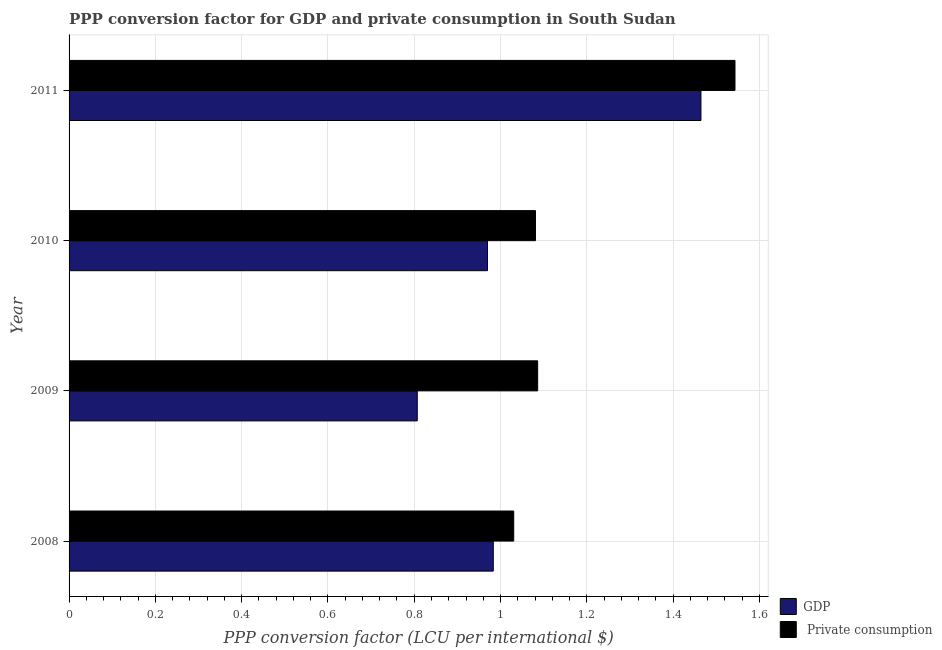How many groups of bars are there?
Keep it short and to the point. 4. Are the number of bars per tick equal to the number of legend labels?
Your answer should be compact. Yes. How many bars are there on the 4th tick from the bottom?
Your response must be concise. 2. In how many cases, is the number of bars for a given year not equal to the number of legend labels?
Give a very brief answer. 0. What is the ppp conversion factor for private consumption in 2008?
Your answer should be very brief. 1.03. Across all years, what is the maximum ppp conversion factor for private consumption?
Your response must be concise. 1.54. Across all years, what is the minimum ppp conversion factor for private consumption?
Keep it short and to the point. 1.03. What is the total ppp conversion factor for private consumption in the graph?
Your response must be concise. 4.74. What is the difference between the ppp conversion factor for gdp in 2009 and that in 2010?
Make the answer very short. -0.16. What is the difference between the ppp conversion factor for private consumption in 2009 and the ppp conversion factor for gdp in 2010?
Offer a very short reply. 0.12. What is the average ppp conversion factor for gdp per year?
Make the answer very short. 1.06. In the year 2009, what is the difference between the ppp conversion factor for private consumption and ppp conversion factor for gdp?
Provide a succinct answer. 0.28. In how many years, is the ppp conversion factor for private consumption greater than 0.6000000000000001 LCU?
Give a very brief answer. 4. What is the ratio of the ppp conversion factor for private consumption in 2009 to that in 2011?
Make the answer very short. 0.7. Is the ppp conversion factor for private consumption in 2009 less than that in 2010?
Provide a succinct answer. No. What is the difference between the highest and the second highest ppp conversion factor for private consumption?
Your answer should be compact. 0.46. What is the difference between the highest and the lowest ppp conversion factor for gdp?
Ensure brevity in your answer.  0.66. In how many years, is the ppp conversion factor for gdp greater than the average ppp conversion factor for gdp taken over all years?
Ensure brevity in your answer.  1. Is the sum of the ppp conversion factor for gdp in 2008 and 2011 greater than the maximum ppp conversion factor for private consumption across all years?
Provide a short and direct response. Yes. What does the 1st bar from the top in 2009 represents?
Make the answer very short.  Private consumption. What does the 2nd bar from the bottom in 2010 represents?
Ensure brevity in your answer.   Private consumption. How many bars are there?
Your answer should be compact. 8. Are all the bars in the graph horizontal?
Your response must be concise. Yes. How many years are there in the graph?
Your answer should be very brief. 4. Does the graph contain any zero values?
Give a very brief answer. No. What is the title of the graph?
Give a very brief answer. PPP conversion factor for GDP and private consumption in South Sudan. Does "Fertility rate" appear as one of the legend labels in the graph?
Make the answer very short. No. What is the label or title of the X-axis?
Ensure brevity in your answer.  PPP conversion factor (LCU per international $). What is the PPP conversion factor (LCU per international $) in GDP in 2008?
Your answer should be compact. 0.98. What is the PPP conversion factor (LCU per international $) of  Private consumption in 2008?
Ensure brevity in your answer.  1.03. What is the PPP conversion factor (LCU per international $) of GDP in 2009?
Your answer should be very brief. 0.81. What is the PPP conversion factor (LCU per international $) of  Private consumption in 2009?
Provide a short and direct response. 1.09. What is the PPP conversion factor (LCU per international $) in GDP in 2010?
Offer a terse response. 0.97. What is the PPP conversion factor (LCU per international $) in  Private consumption in 2010?
Offer a very short reply. 1.08. What is the PPP conversion factor (LCU per international $) of GDP in 2011?
Provide a short and direct response. 1.46. What is the PPP conversion factor (LCU per international $) in  Private consumption in 2011?
Your response must be concise. 1.54. Across all years, what is the maximum PPP conversion factor (LCU per international $) of GDP?
Your answer should be very brief. 1.46. Across all years, what is the maximum PPP conversion factor (LCU per international $) of  Private consumption?
Your answer should be very brief. 1.54. Across all years, what is the minimum PPP conversion factor (LCU per international $) of GDP?
Give a very brief answer. 0.81. Across all years, what is the minimum PPP conversion factor (LCU per international $) in  Private consumption?
Ensure brevity in your answer.  1.03. What is the total PPP conversion factor (LCU per international $) in GDP in the graph?
Provide a short and direct response. 4.22. What is the total PPP conversion factor (LCU per international $) in  Private consumption in the graph?
Give a very brief answer. 4.74. What is the difference between the PPP conversion factor (LCU per international $) of GDP in 2008 and that in 2009?
Offer a very short reply. 0.18. What is the difference between the PPP conversion factor (LCU per international $) of  Private consumption in 2008 and that in 2009?
Offer a terse response. -0.06. What is the difference between the PPP conversion factor (LCU per international $) of GDP in 2008 and that in 2010?
Keep it short and to the point. 0.01. What is the difference between the PPP conversion factor (LCU per international $) of  Private consumption in 2008 and that in 2010?
Keep it short and to the point. -0.05. What is the difference between the PPP conversion factor (LCU per international $) in GDP in 2008 and that in 2011?
Keep it short and to the point. -0.48. What is the difference between the PPP conversion factor (LCU per international $) of  Private consumption in 2008 and that in 2011?
Your response must be concise. -0.51. What is the difference between the PPP conversion factor (LCU per international $) in GDP in 2009 and that in 2010?
Your answer should be very brief. -0.16. What is the difference between the PPP conversion factor (LCU per international $) in  Private consumption in 2009 and that in 2010?
Keep it short and to the point. 0.01. What is the difference between the PPP conversion factor (LCU per international $) of GDP in 2009 and that in 2011?
Your answer should be compact. -0.66. What is the difference between the PPP conversion factor (LCU per international $) of  Private consumption in 2009 and that in 2011?
Provide a succinct answer. -0.46. What is the difference between the PPP conversion factor (LCU per international $) of GDP in 2010 and that in 2011?
Your answer should be compact. -0.49. What is the difference between the PPP conversion factor (LCU per international $) in  Private consumption in 2010 and that in 2011?
Your response must be concise. -0.46. What is the difference between the PPP conversion factor (LCU per international $) of GDP in 2008 and the PPP conversion factor (LCU per international $) of  Private consumption in 2009?
Offer a very short reply. -0.1. What is the difference between the PPP conversion factor (LCU per international $) in GDP in 2008 and the PPP conversion factor (LCU per international $) in  Private consumption in 2010?
Make the answer very short. -0.1. What is the difference between the PPP conversion factor (LCU per international $) in GDP in 2008 and the PPP conversion factor (LCU per international $) in  Private consumption in 2011?
Your answer should be compact. -0.56. What is the difference between the PPP conversion factor (LCU per international $) of GDP in 2009 and the PPP conversion factor (LCU per international $) of  Private consumption in 2010?
Ensure brevity in your answer.  -0.27. What is the difference between the PPP conversion factor (LCU per international $) of GDP in 2009 and the PPP conversion factor (LCU per international $) of  Private consumption in 2011?
Ensure brevity in your answer.  -0.74. What is the difference between the PPP conversion factor (LCU per international $) of GDP in 2010 and the PPP conversion factor (LCU per international $) of  Private consumption in 2011?
Your response must be concise. -0.57. What is the average PPP conversion factor (LCU per international $) of GDP per year?
Provide a short and direct response. 1.06. What is the average PPP conversion factor (LCU per international $) of  Private consumption per year?
Your answer should be compact. 1.19. In the year 2008, what is the difference between the PPP conversion factor (LCU per international $) in GDP and PPP conversion factor (LCU per international $) in  Private consumption?
Make the answer very short. -0.05. In the year 2009, what is the difference between the PPP conversion factor (LCU per international $) of GDP and PPP conversion factor (LCU per international $) of  Private consumption?
Give a very brief answer. -0.28. In the year 2010, what is the difference between the PPP conversion factor (LCU per international $) of GDP and PPP conversion factor (LCU per international $) of  Private consumption?
Your answer should be very brief. -0.11. In the year 2011, what is the difference between the PPP conversion factor (LCU per international $) in GDP and PPP conversion factor (LCU per international $) in  Private consumption?
Ensure brevity in your answer.  -0.08. What is the ratio of the PPP conversion factor (LCU per international $) in GDP in 2008 to that in 2009?
Offer a terse response. 1.22. What is the ratio of the PPP conversion factor (LCU per international $) of  Private consumption in 2008 to that in 2009?
Your answer should be compact. 0.95. What is the ratio of the PPP conversion factor (LCU per international $) in GDP in 2008 to that in 2010?
Offer a terse response. 1.01. What is the ratio of the PPP conversion factor (LCU per international $) of  Private consumption in 2008 to that in 2010?
Your response must be concise. 0.95. What is the ratio of the PPP conversion factor (LCU per international $) of GDP in 2008 to that in 2011?
Offer a very short reply. 0.67. What is the ratio of the PPP conversion factor (LCU per international $) of  Private consumption in 2008 to that in 2011?
Provide a succinct answer. 0.67. What is the ratio of the PPP conversion factor (LCU per international $) in GDP in 2009 to that in 2010?
Provide a succinct answer. 0.83. What is the ratio of the PPP conversion factor (LCU per international $) of  Private consumption in 2009 to that in 2010?
Give a very brief answer. 1. What is the ratio of the PPP conversion factor (LCU per international $) in GDP in 2009 to that in 2011?
Your answer should be very brief. 0.55. What is the ratio of the PPP conversion factor (LCU per international $) in  Private consumption in 2009 to that in 2011?
Your response must be concise. 0.7. What is the ratio of the PPP conversion factor (LCU per international $) in GDP in 2010 to that in 2011?
Your response must be concise. 0.66. What is the ratio of the PPP conversion factor (LCU per international $) of  Private consumption in 2010 to that in 2011?
Provide a succinct answer. 0.7. What is the difference between the highest and the second highest PPP conversion factor (LCU per international $) in GDP?
Give a very brief answer. 0.48. What is the difference between the highest and the second highest PPP conversion factor (LCU per international $) of  Private consumption?
Offer a terse response. 0.46. What is the difference between the highest and the lowest PPP conversion factor (LCU per international $) of GDP?
Ensure brevity in your answer.  0.66. What is the difference between the highest and the lowest PPP conversion factor (LCU per international $) of  Private consumption?
Your response must be concise. 0.51. 